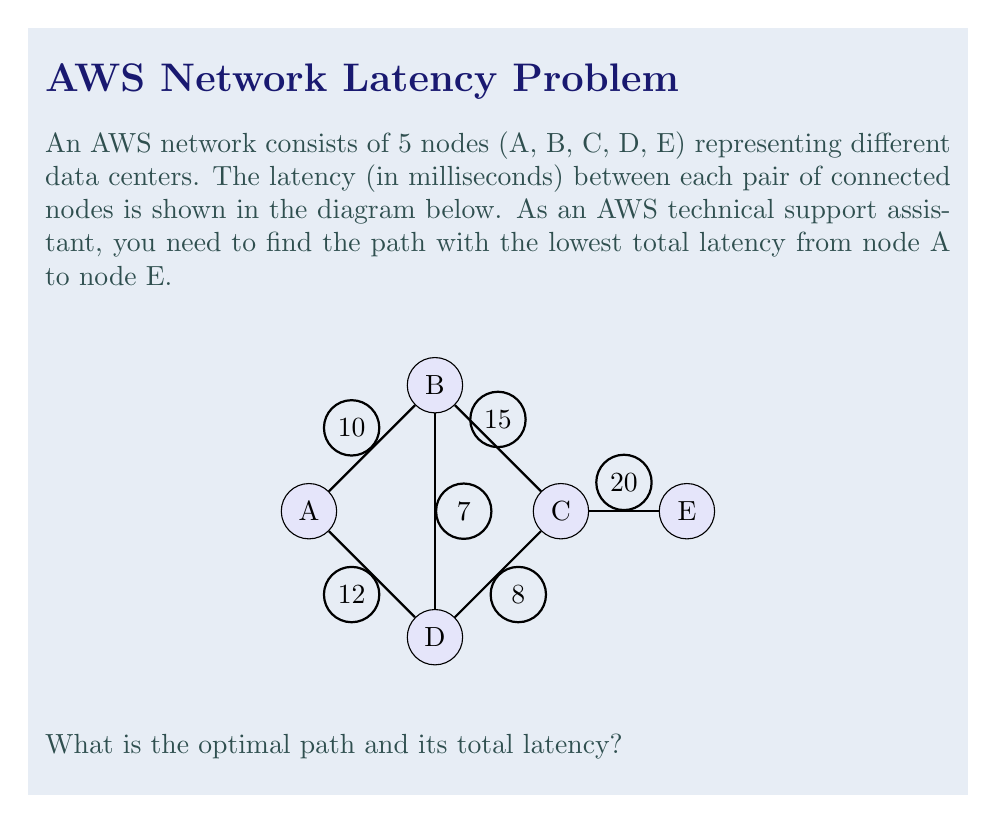Show me your answer to this math problem. To solve this problem, we need to consider all possible paths from A to E and calculate their total latencies. The paths are:

1. A -> B -> C -> E
2. A -> D -> C -> E
3. A -> B -> D -> C -> E

Let's calculate the latency for each path:

1. A -> B -> C -> E
   Latency = $10 + 15 + 20 = 45$ ms

2. A -> D -> C -> E
   Latency = $12 + 8 + 20 = 40$ ms

3. A -> B -> D -> C -> E
   Latency = $10 + 7 + 8 + 20 = 45$ ms

The path with the lowest total latency is A -> D -> C -> E, with a total latency of 40 ms.

To verify that this is indeed the optimal path, we can see that any other route would involve either backtracking or using longer segments, which would result in higher total latency.
Answer: A -> D -> C -> E, 40 ms 